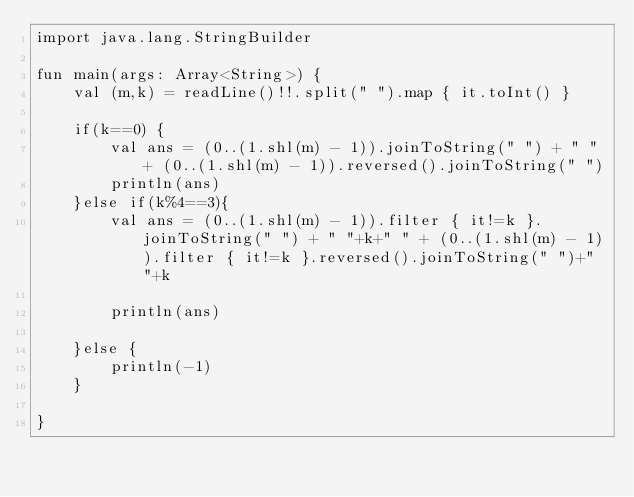Convert code to text. <code><loc_0><loc_0><loc_500><loc_500><_Kotlin_>import java.lang.StringBuilder

fun main(args: Array<String>) {
    val (m,k) = readLine()!!.split(" ").map { it.toInt() }
    
    if(k==0) {
        val ans = (0..(1.shl(m) - 1)).joinToString(" ") + " " + (0..(1.shl(m) - 1)).reversed().joinToString(" ")
        println(ans)
    }else if(k%4==3){
        val ans = (0..(1.shl(m) - 1)).filter { it!=k }.joinToString(" ") + " "+k+" " + (0..(1.shl(m) - 1)).filter { it!=k }.reversed().joinToString(" ")+" "+k
        
        println(ans)
        
    }else {
        println(-1)
    }

}

</code> 